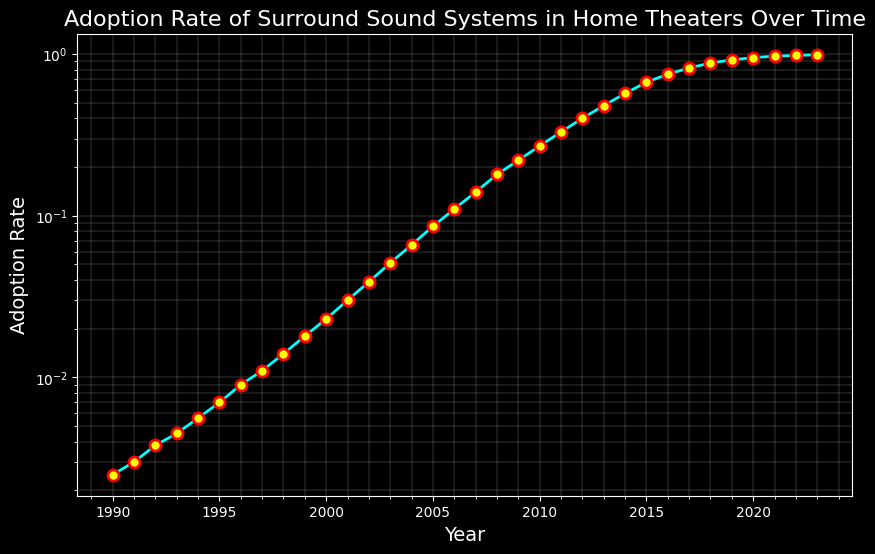What was the adoption rate of surround sound systems in 2000? To find the adoption rate for 2000, look for the year along the x-axis and find the corresponding point on the y-axis.
Answer: 0.023 In which year did the adoption rate of surround sound systems exceed 0.1 for the first time? Locate the adoption rate of 0.1 on the y-axis and trace it horizontally until you meet the curve, then go downwards to the year on the x-axis.
Answer: 2006 By how much did the adoption rate change between 1995 and 2005? Find the adoption rates for 1995 and 2005 (0.007 and 0.086 respectively), then subtract the former from the latter. 0.086 - 0.007 = 0.079
Answer: 0.079 What was the compound annual growth rate (CAGR) from 1990 to 2023? The formula for CAGR is [(Ending Value/Beginning Value)^(1/Number of Years)] - 1. Here, [(0.99/0.0025)^(1/33)] - 1 = ~0.151.
Answer: 15.1% Which year marks the steepest growth in adoption rate based on the curve's visual steepness? Identify the segment of the plotted line with the greatest slope. This typically appears visually steeper around 2010.
Answer: 2010 How does the adoption rate in 2020 compare to that in 2000? Look at the points for 2020 and 2000, and see how they relate in terms of position on the y-axis.
Answer: Much higher in 2020 What is the average adoption rate from 2010 to 2020? Sum the adoption rates from 2010 to 2020 and divide by the number of years (11). (0.27 + 0.33 + 0.4 + 0.48 + 0.57 + 0.67 + 0.75 + 0.82 + 0.88 + 0.92 + 0.95) / 11 = 0.644
Answer: 0.644 How many years did it take for the adoption rate to go from 0.01% to 1%? Identify the years where adoption rates were approximately 0.01 (close to 1991) and 1% (close to 2023), then subtract the earlier year from the later year. The span is 2023 - 1991 = 32 years.
Answer: 32 Compare the adoption rate growth between decades 1990-2000 and 2010-2020. Calculate the change in adoption rates for both decades: 1990-2000 (0.023 - 0.0025 = 0.0205) and 2010-2020 (0.95 - 0.27 = 0.68).
Answer: Much faster in 2010-2020 